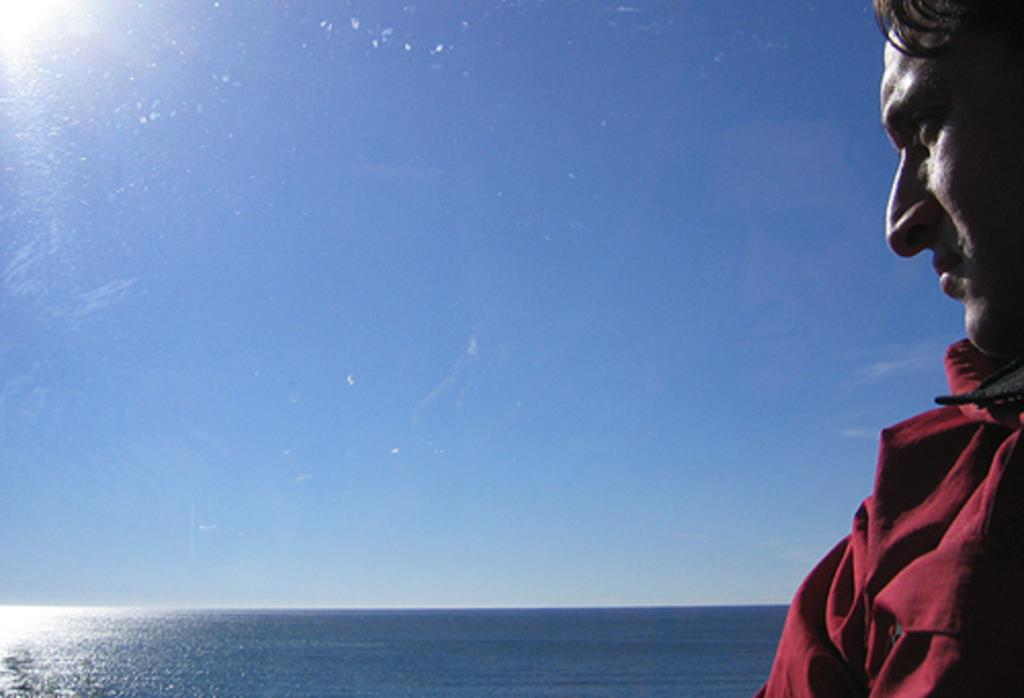Who or what is present in the image? There is a person in the image. What can be seen in the background of the image? Water and the sky are visible in the background of the image. What type of plants can be seen growing on the trains in the image? There are no trains or plants present in the image. 